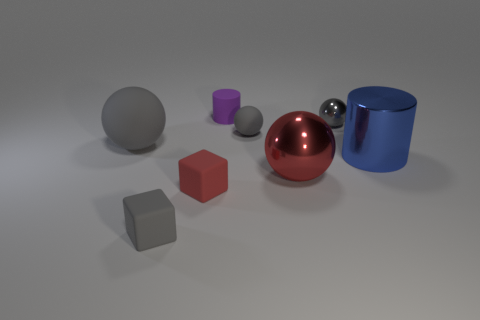Subtract all yellow cylinders. How many gray balls are left? 3 Subtract 1 balls. How many balls are left? 3 Subtract all purple balls. Subtract all cyan blocks. How many balls are left? 4 Add 1 blocks. How many objects exist? 9 Subtract all cylinders. How many objects are left? 6 Subtract all small cyan metallic objects. Subtract all red spheres. How many objects are left? 7 Add 3 red spheres. How many red spheres are left? 4 Add 3 large gray shiny cubes. How many large gray shiny cubes exist? 3 Subtract 1 blue cylinders. How many objects are left? 7 